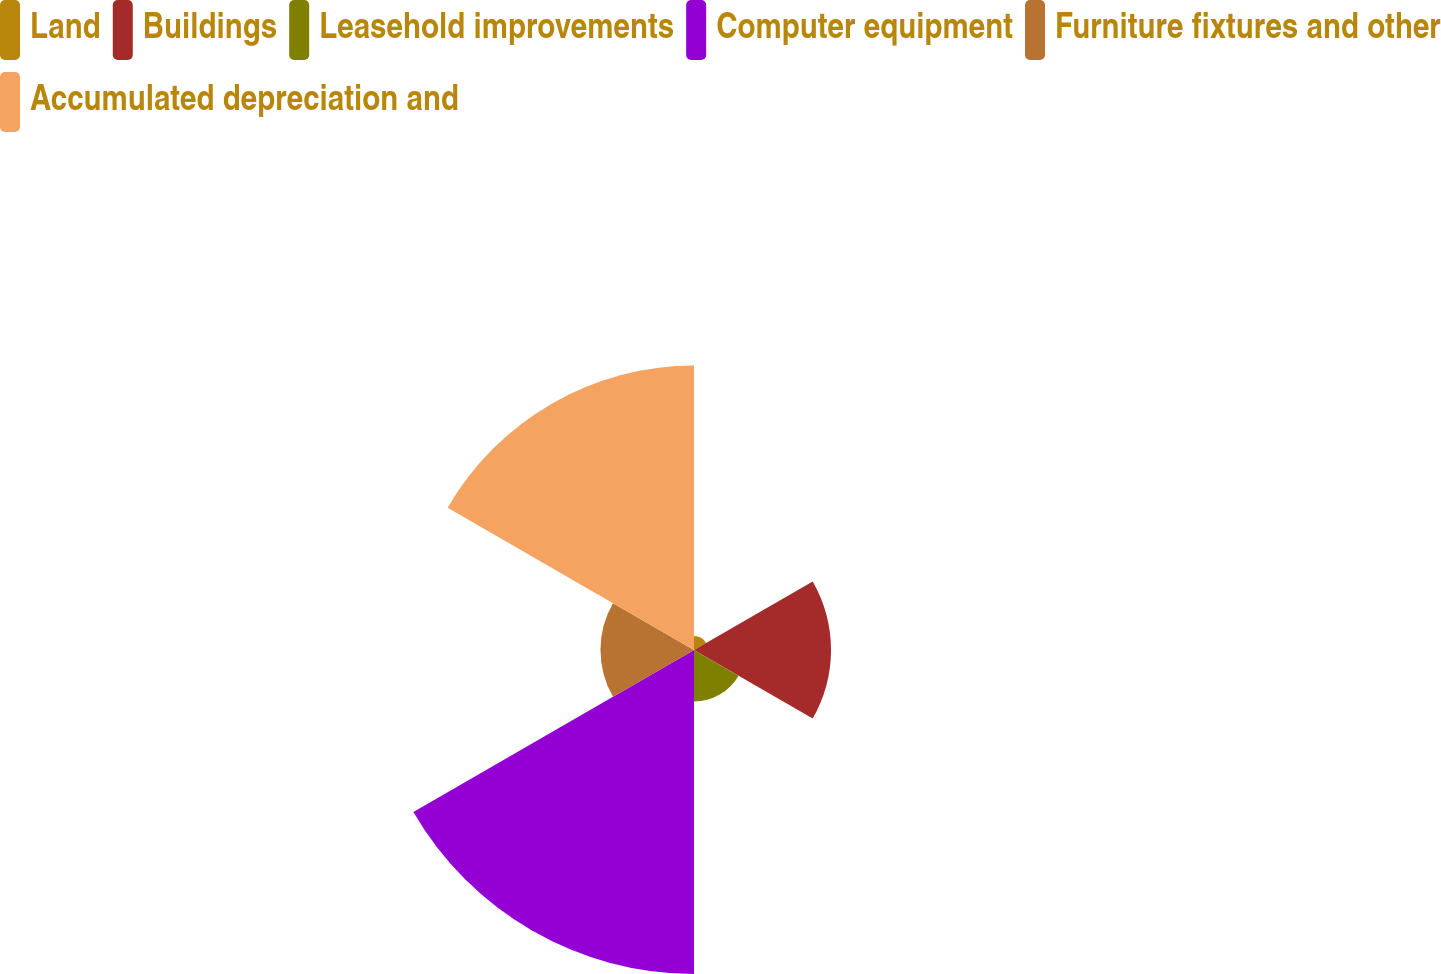Convert chart to OTSL. <chart><loc_0><loc_0><loc_500><loc_500><pie_chart><fcel>Land<fcel>Buildings<fcel>Leasehold improvements<fcel>Computer equipment<fcel>Furniture fixtures and other<fcel>Accumulated depreciation and<nl><fcel>1.55%<fcel>15.15%<fcel>5.69%<fcel>35.82%<fcel>10.34%<fcel>31.45%<nl></chart> 